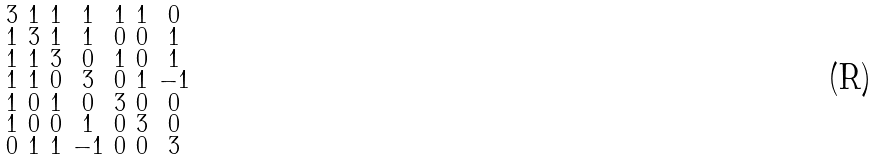Convert formula to latex. <formula><loc_0><loc_0><loc_500><loc_500>\begin{smallmatrix} 3 & 1 & 1 & 1 & 1 & 1 & 0 \\ 1 & 3 & 1 & 1 & 0 & 0 & 1 \\ 1 & 1 & 3 & 0 & 1 & 0 & 1 \\ 1 & 1 & 0 & 3 & 0 & 1 & - 1 \\ 1 & 0 & 1 & 0 & 3 & 0 & 0 \\ 1 & 0 & 0 & 1 & 0 & 3 & 0 \\ 0 & 1 & 1 & - 1 & 0 & 0 & 3 \end{smallmatrix}</formula> 